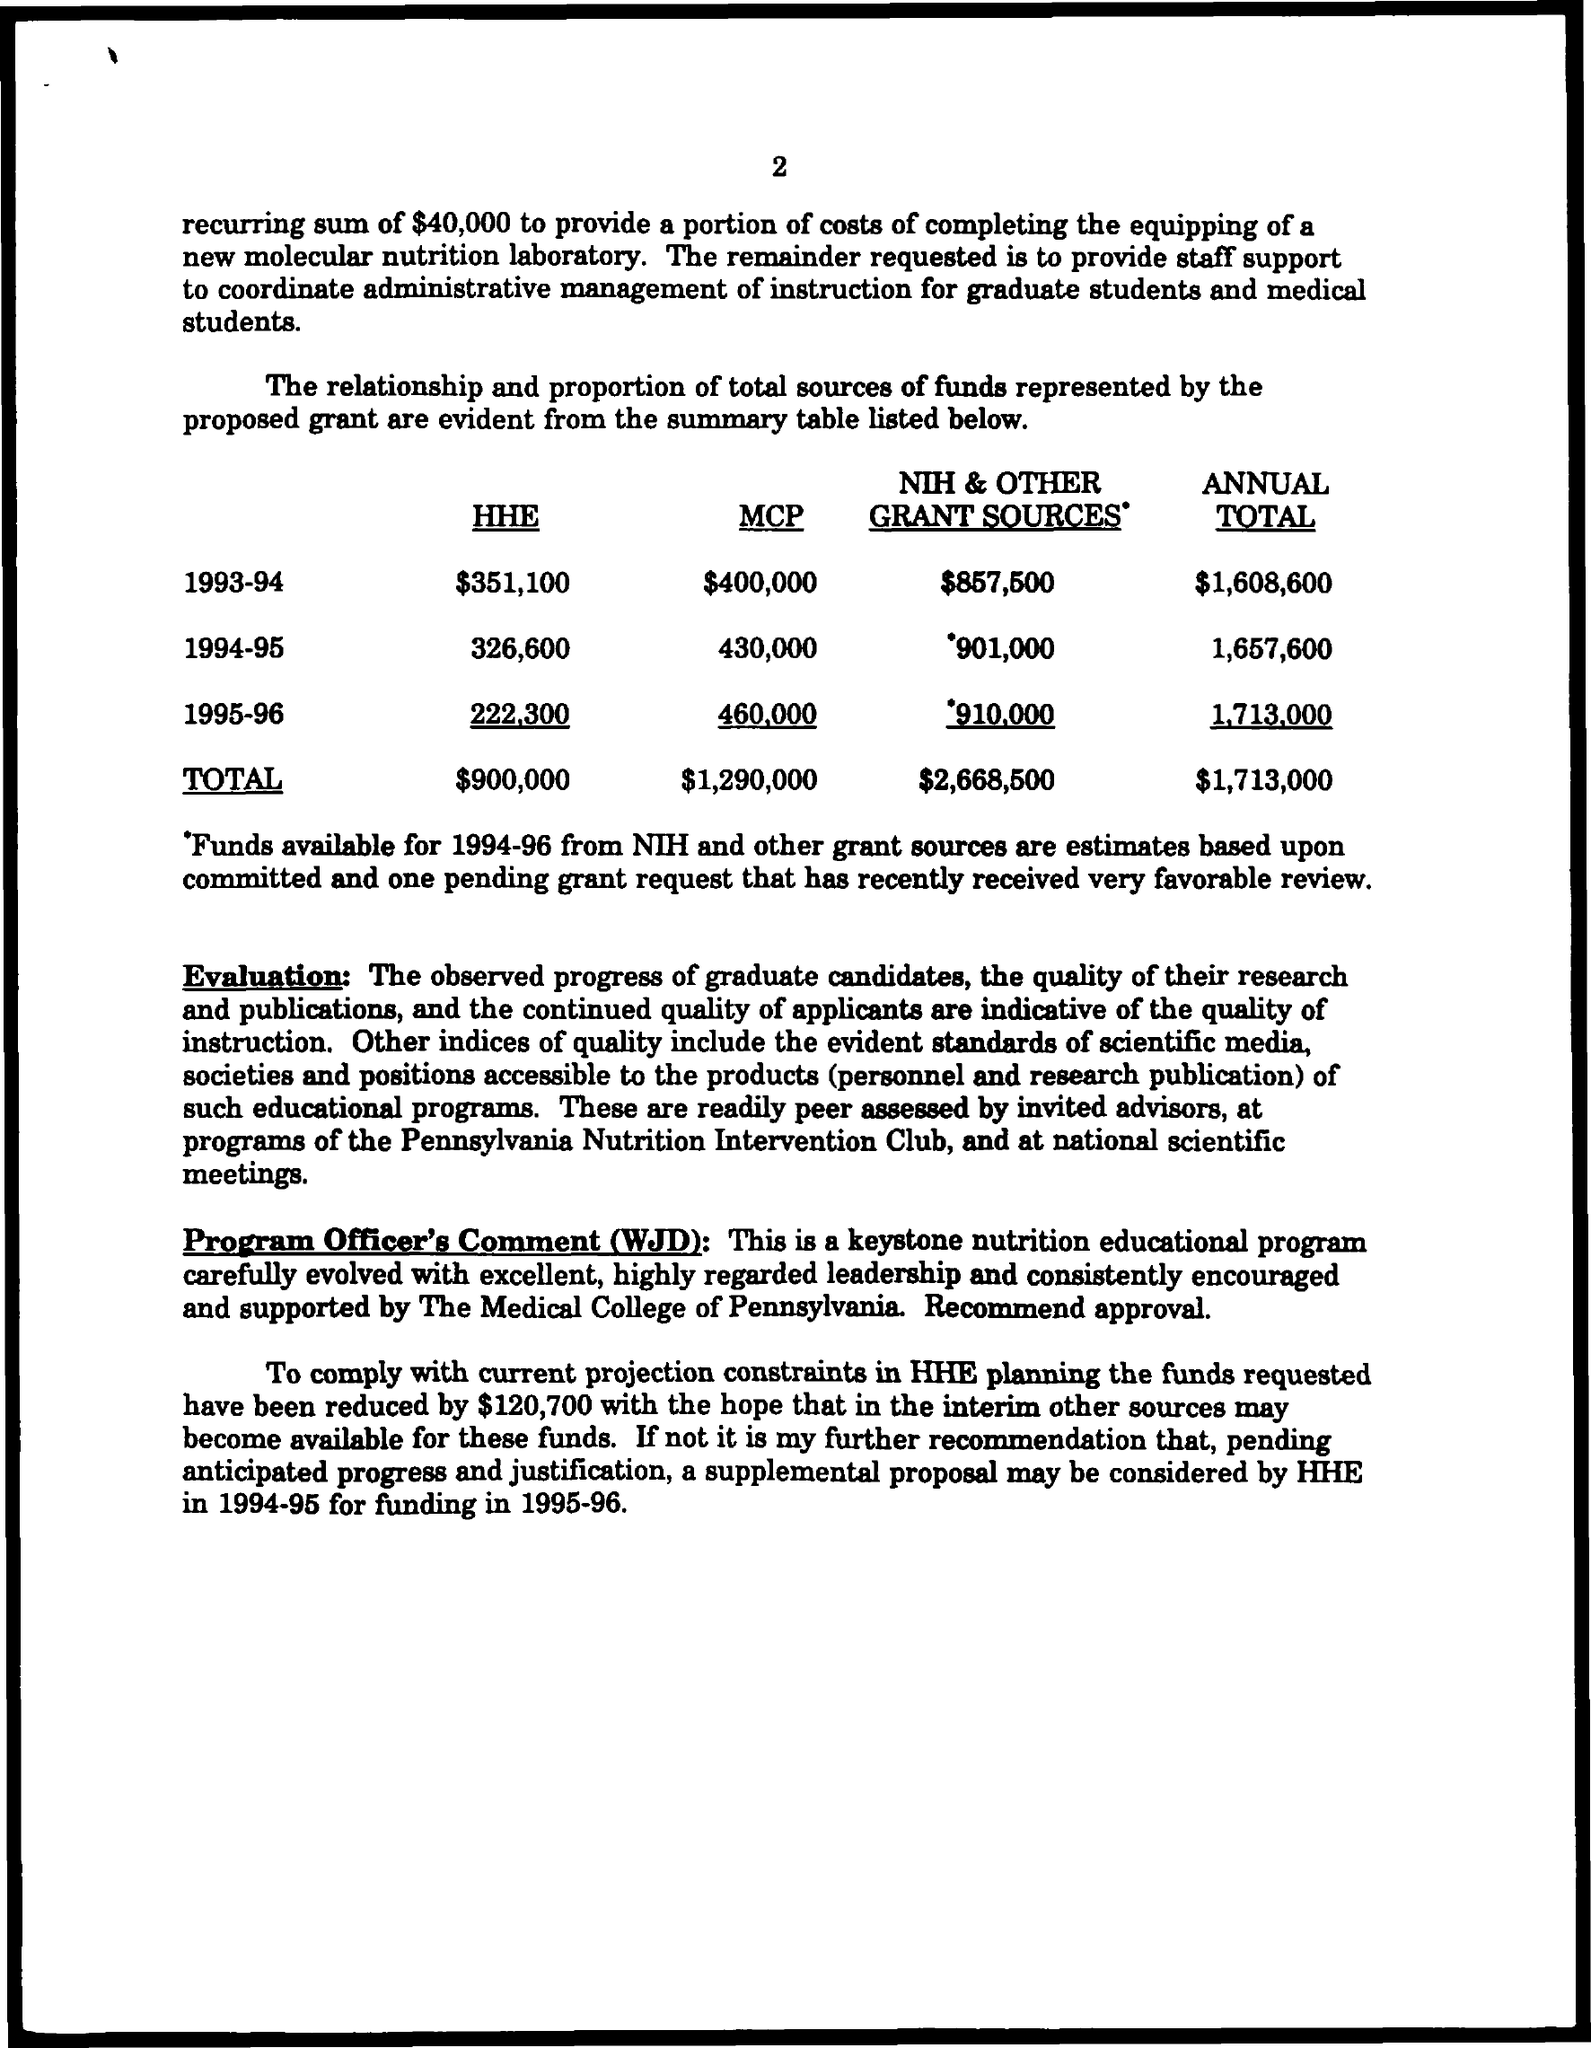Indicate a few pertinent items in this graphic. What is the page number? It is 2.. In the year 1994-95, the annual total was 1,657,600. In the fiscal year 1993-1994, the Hazardous Materials Emergency Preparedness (HHE) grant amounted to $351,100. The annual total in the year 1993-1994 was $1,608,600. In the year 1993-1994, the National Institutes of Health (NIH) and other grant sources provided a total of $857,500 for a specific purpose. 